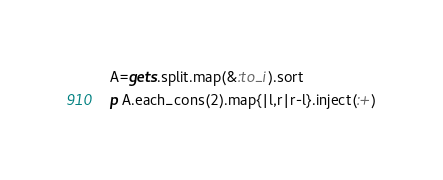Convert code to text. <code><loc_0><loc_0><loc_500><loc_500><_Ruby_>A=gets.split.map(&:to_i).sort
p A.each_cons(2).map{|l,r|r-l}.inject(:+)</code> 